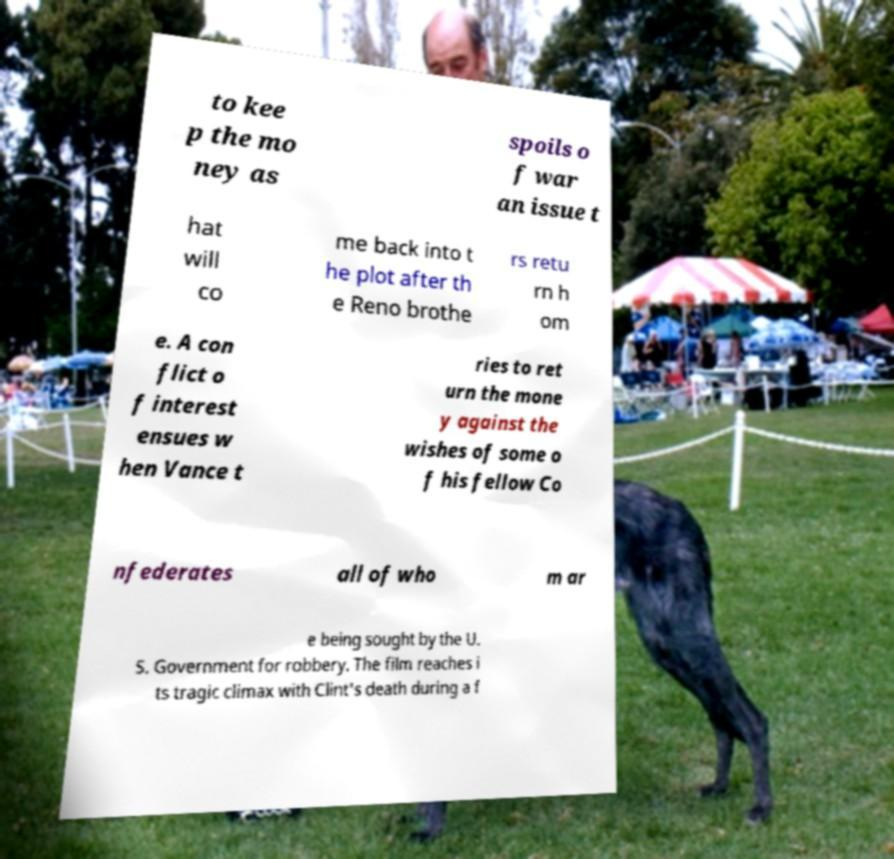Could you extract and type out the text from this image? to kee p the mo ney as spoils o f war an issue t hat will co me back into t he plot after th e Reno brothe rs retu rn h om e. A con flict o f interest ensues w hen Vance t ries to ret urn the mone y against the wishes of some o f his fellow Co nfederates all of who m ar e being sought by the U. S. Government for robbery. The film reaches i ts tragic climax with Clint's death during a f 